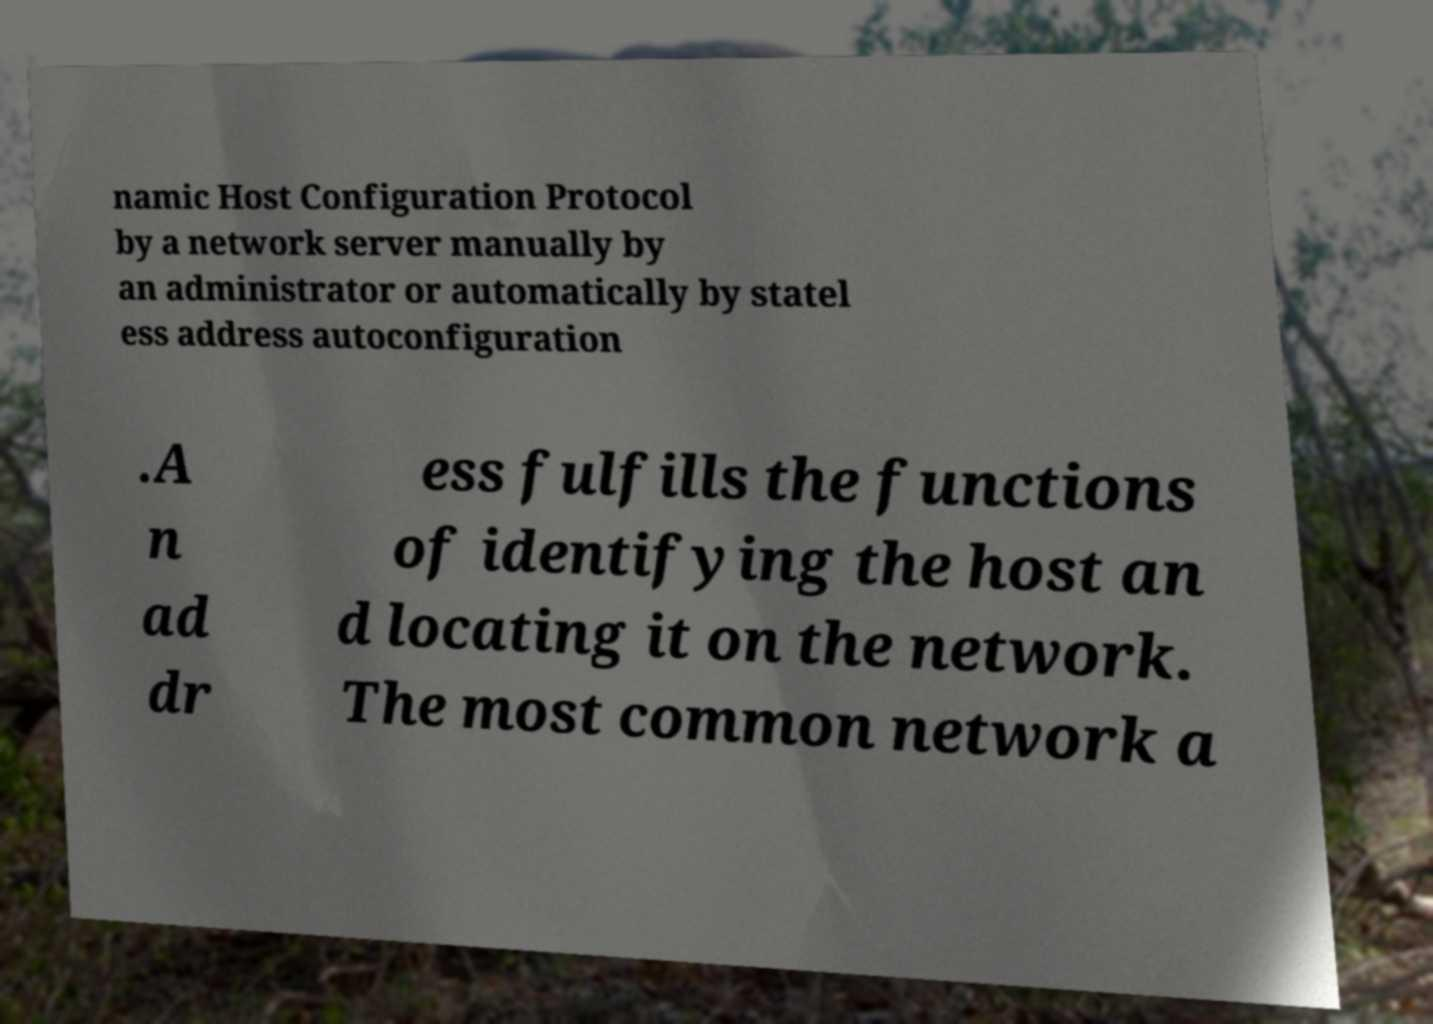Could you assist in decoding the text presented in this image and type it out clearly? namic Host Configuration Protocol by a network server manually by an administrator or automatically by statel ess address autoconfiguration .A n ad dr ess fulfills the functions of identifying the host an d locating it on the network. The most common network a 